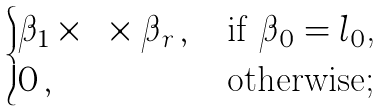Convert formula to latex. <formula><loc_0><loc_0><loc_500><loc_500>\begin{cases} \beta _ { 1 } \times \dots \times \beta _ { r } \, , \, & \text {if $\beta_{0}=l_{0}$,} \\ 0 \, , & \text {otherwise;} \end{cases}</formula> 